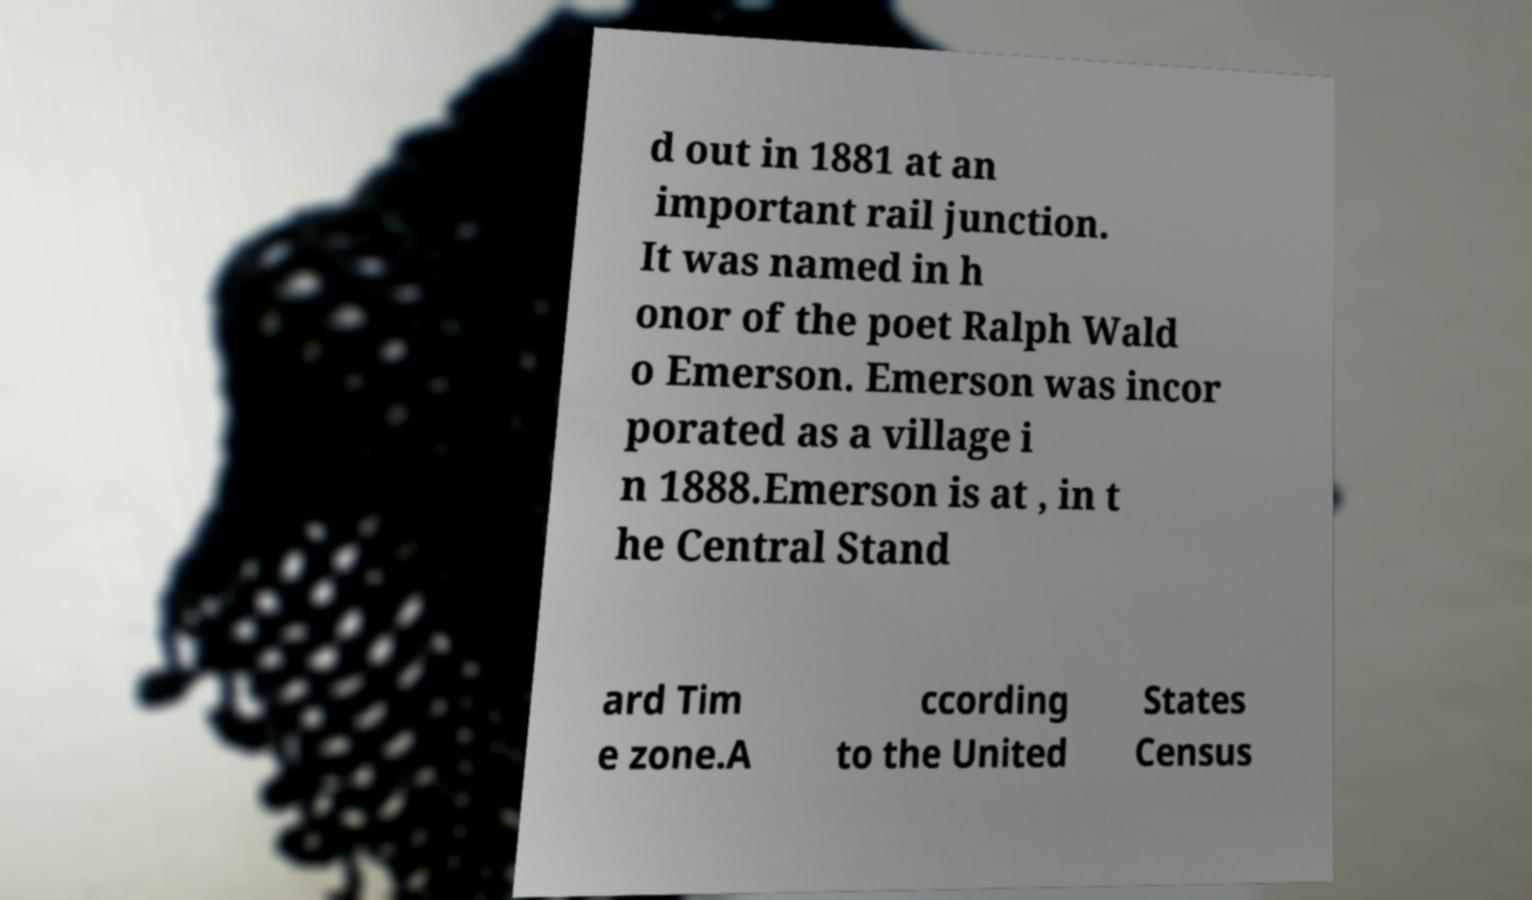What messages or text are displayed in this image? I need them in a readable, typed format. d out in 1881 at an important rail junction. It was named in h onor of the poet Ralph Wald o Emerson. Emerson was incor porated as a village i n 1888.Emerson is at , in t he Central Stand ard Tim e zone.A ccording to the United States Census 